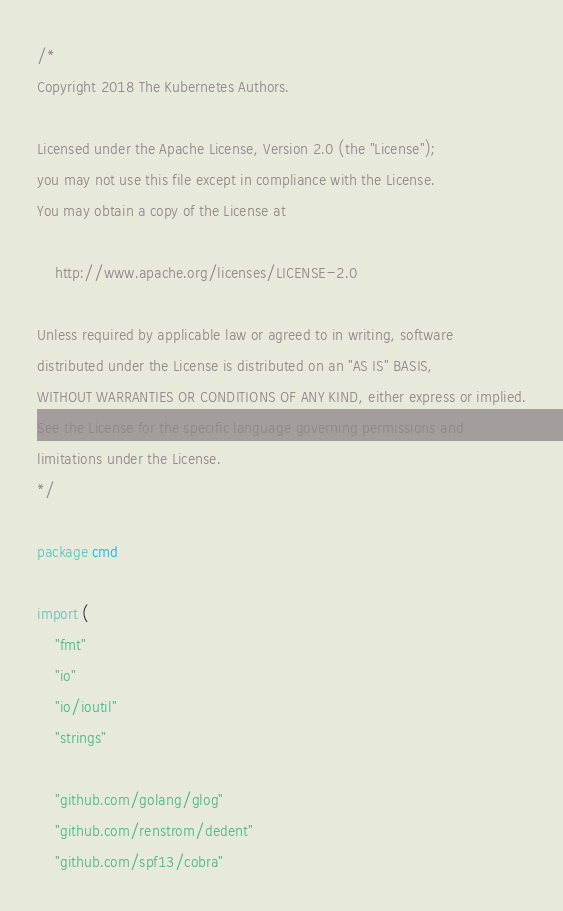<code> <loc_0><loc_0><loc_500><loc_500><_Go_>/*
Copyright 2018 The Kubernetes Authors.

Licensed under the Apache License, Version 2.0 (the "License");
you may not use this file except in compliance with the License.
You may obtain a copy of the License at

    http://www.apache.org/licenses/LICENSE-2.0

Unless required by applicable law or agreed to in writing, software
distributed under the License is distributed on an "AS IS" BASIS,
WITHOUT WARRANTIES OR CONDITIONS OF ANY KIND, either express or implied.
See the License for the specific language governing permissions and
limitations under the License.
*/

package cmd

import (
	"fmt"
	"io"
	"io/ioutil"
	"strings"

	"github.com/golang/glog"
	"github.com/renstrom/dedent"
	"github.com/spf13/cobra"</code> 